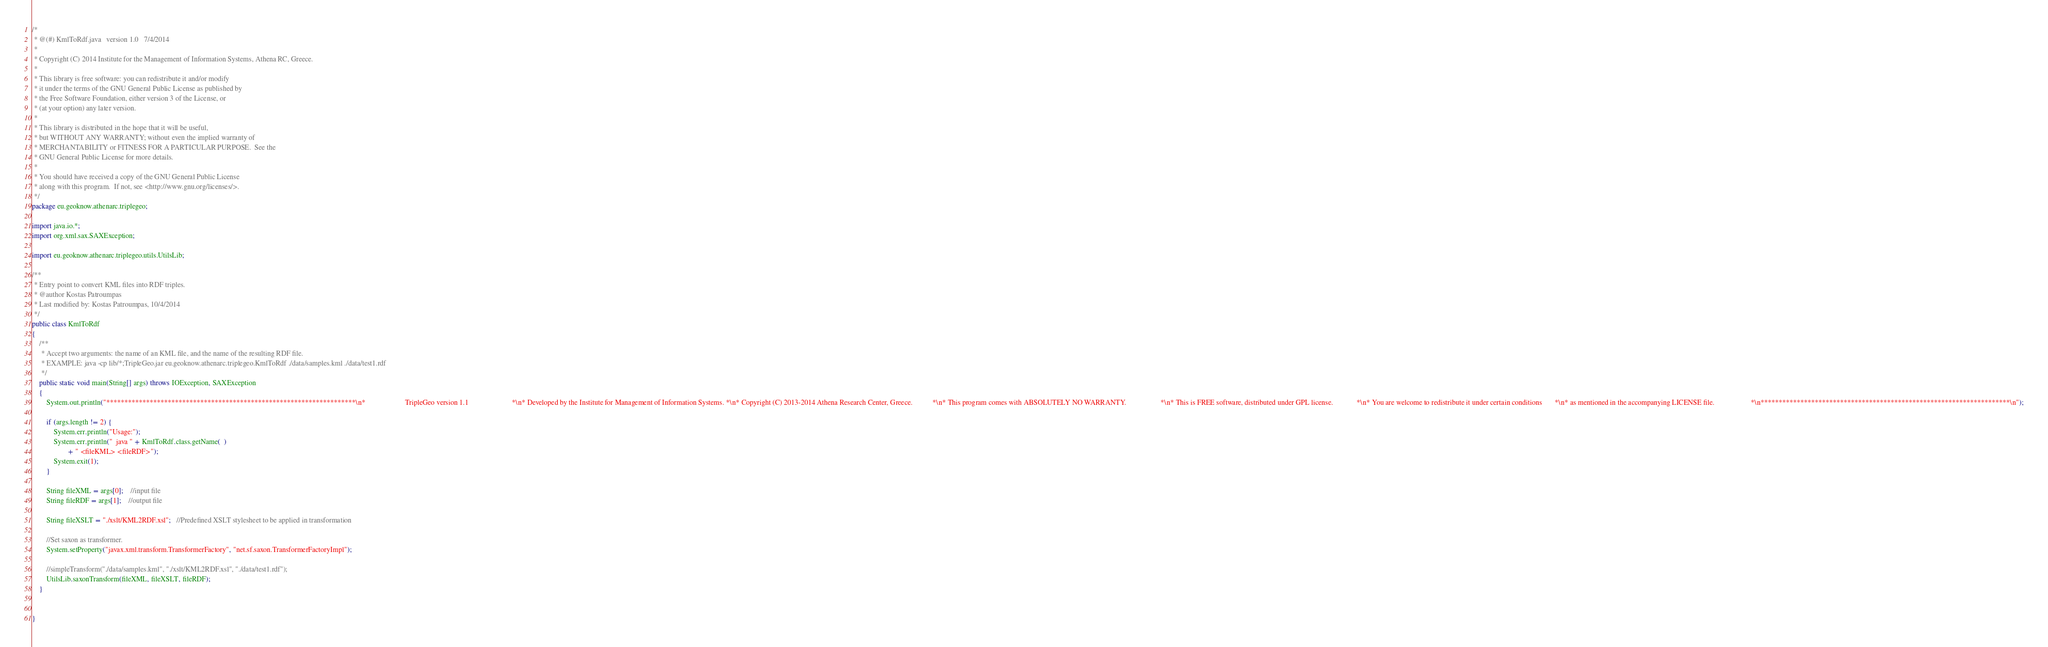Convert code to text. <code><loc_0><loc_0><loc_500><loc_500><_Java_>/*
 * @(#) KmlToRdf.java	version 1.0   7/4/2014
 *
 * Copyright (C) 2014 Institute for the Management of Information Systems, Athena RC, Greece.
 *
 * This library is free software: you can redistribute it and/or modify
 * it under the terms of the GNU General Public License as published by
 * the Free Software Foundation, either version 3 of the License, or
 * (at your option) any later version.
 * 
 * This library is distributed in the hope that it will be useful,
 * but WITHOUT ANY WARRANTY; without even the implied warranty of
 * MERCHANTABILITY or FITNESS FOR A PARTICULAR PURPOSE.  See the
 * GNU General Public License for more details.
 * 
 * You should have received a copy of the GNU General Public License
 * along with this program.  If not, see <http://www.gnu.org/licenses/>.
 */
package eu.geoknow.athenarc.triplegeo;

import java.io.*;
import org.xml.sax.SAXException;

import eu.geoknow.athenarc.triplegeo.utils.UtilsLib;

/**
 * Entry point to convert KML files into RDF triples.
 * @author Kostas Patroumpas
 * Last modified by: Kostas Patroumpas, 10/4/2014
 */
public class KmlToRdf 
{
	/**
     * Accept two arguments: the name of an KML file, and the name of the resulting RDF file.
     * EXAMPLE: java -cp lib/*;TripleGeo.jar eu.geoknow.athenarc.triplegeo.KmlToRdf ./data/samples.kml ./data/test1.rdf
     */
    public static void main(String[] args) throws IOException, SAXException 
    {
    	System.out.println("*********************************************************************\n*                      TripleGeo version 1.1                        *\n* Developed by the Institute for Management of Information Systems. *\n* Copyright (C) 2013-2014 Athena Research Center, Greece.           *\n* This program comes with ABSOLUTELY NO WARRANTY.                   *\n* This is FREE software, distributed under GPL license.             *\n* You are welcome to redistribute it under certain conditions       *\n* as mentioned in the accompanying LICENSE file.                    *\n*********************************************************************\n");
    	
        if (args.length != 2) {
            System.err.println("Usage:");
            System.err.println("  java " + KmlToRdf.class.getName(  )
                    + " <fileKML> <fileRDF>");
            System.exit(1);
        }

        String fileXML = args[0];    //input file
        String fileRDF = args[1];    //output file
        
        String fileXSLT = "./xslt/KML2RDF.xsl";   //Predefined XSLT stylesheet to be applied in transformation
        
        //Set saxon as transformer.  
        System.setProperty("javax.xml.transform.TransformerFactory", "net.sf.saxon.TransformerFactoryImpl");  
  
        //simpleTransform("./data/samples.kml", "./xslt/KML2RDF.xsl", "./data/test1.rdf");  
        UtilsLib.saxonTransform(fileXML, fileXSLT, fileRDF);  
    }
   

}
</code> 